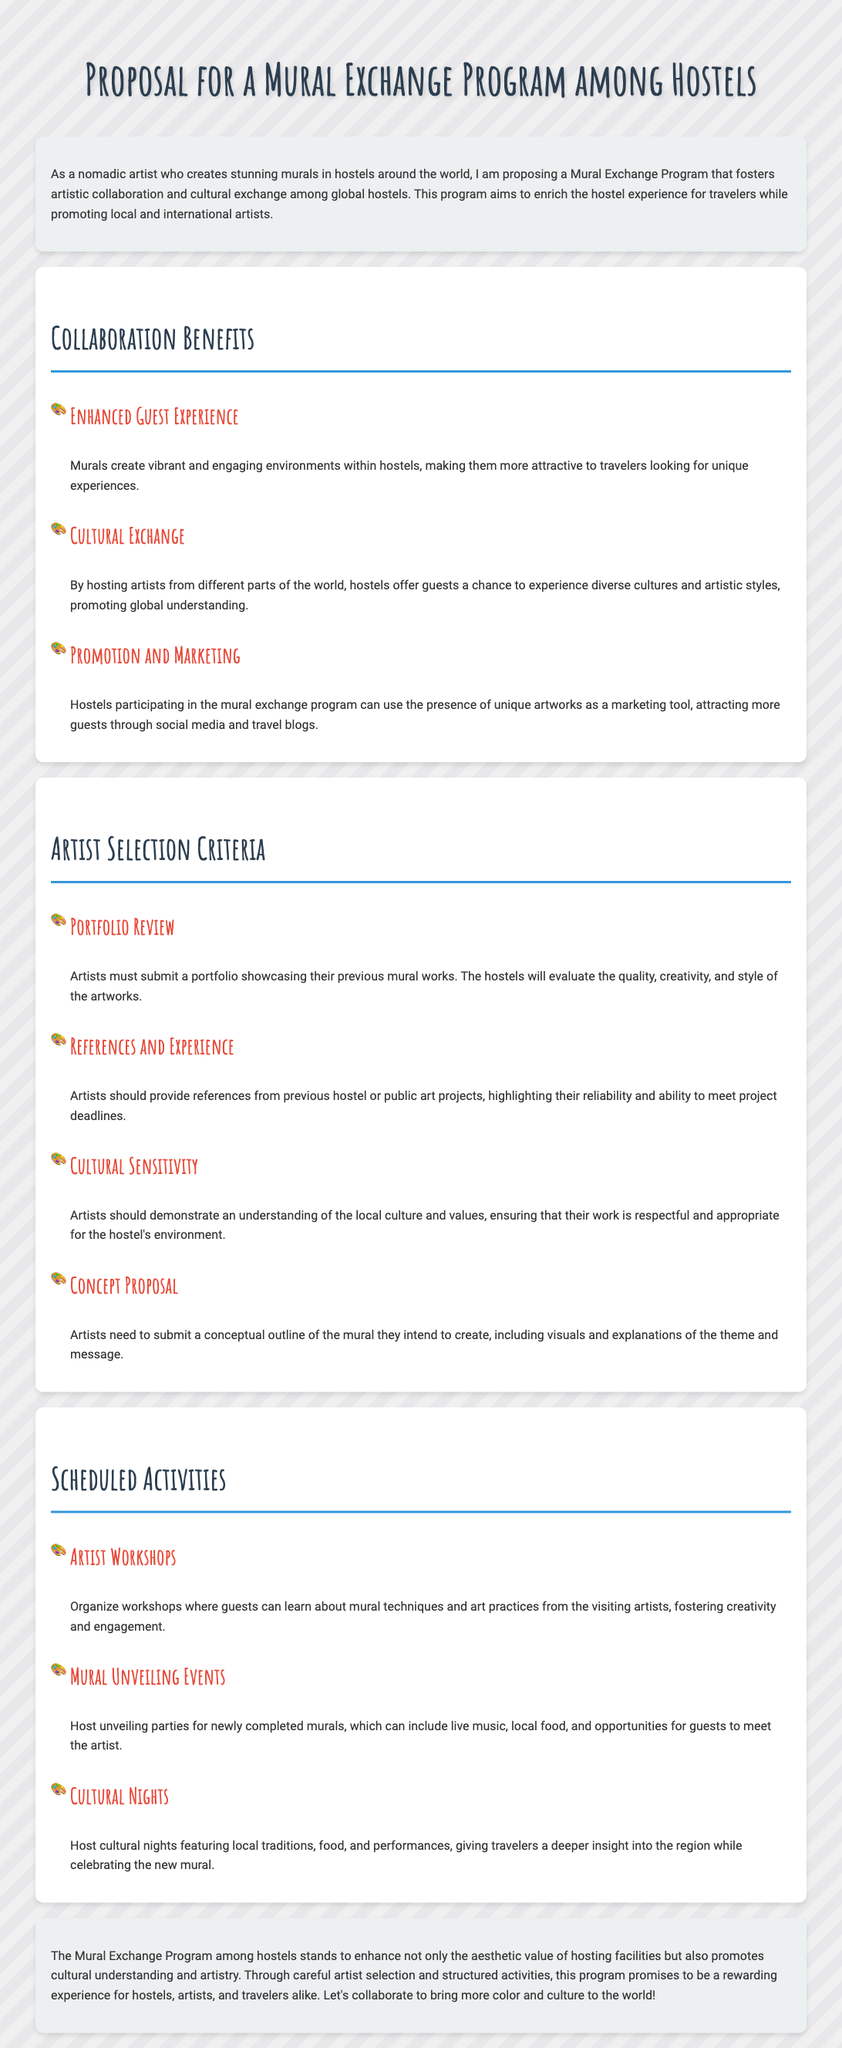what is the title of the proposal? The title of the proposal is stated at the beginning of the document, which is for a Mural Exchange Program.
Answer: Mural Exchange Program Proposal what benefits does the mural program provide for guest experience? One of the benefits listed in the document is that murals create vibrant and engaging environments within hostels.
Answer: Enhanced Guest Experience how many criteria are there for artist selection? The section on Artist Selection Criteria outlines four specific criteria for selecting artists.
Answer: Four what type of events are suggested for mural unveiling? The proposal suggests hosting unveiling parties for newly completed murals.
Answer: Mural Unveiling Events what is required from artists in the concept proposal? Artists need to submit a conceptual outline of the mural they intend to create, along with visuals and explanations.
Answer: Conceptual outline which aspect of the program promotes global understanding? The collaboration encourages cultural exchange by hosting artists from different parts of the world.
Answer: Cultural Exchange how many scheduled activities are proposed in the document? The Scheduled Activities section lists three activities that are planned during the program.
Answer: Three what type of workshops are mentioned for guests? The program includes workshops where guests can learn about mural techniques and art practices.
Answer: Artist Workshops what overall impact does the Mural Exchange Program aim to achieve? The program is designed to enhance the aesthetic value of hosting facilities while promoting cultural understanding and artistry.
Answer: Enhance aesthetic value and cultural understanding 